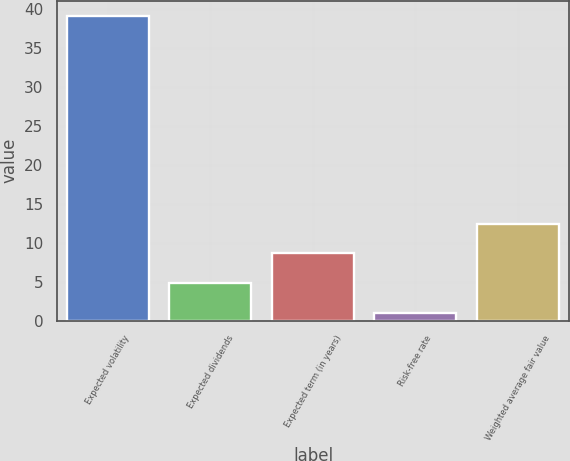Convert chart. <chart><loc_0><loc_0><loc_500><loc_500><bar_chart><fcel>Expected volatility<fcel>Expected dividends<fcel>Expected term (in years)<fcel>Risk-free rate<fcel>Weighted average fair value<nl><fcel>39.12<fcel>4.82<fcel>8.63<fcel>1.01<fcel>12.44<nl></chart> 